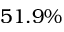<formula> <loc_0><loc_0><loc_500><loc_500>5 1 . 9 \%</formula> 